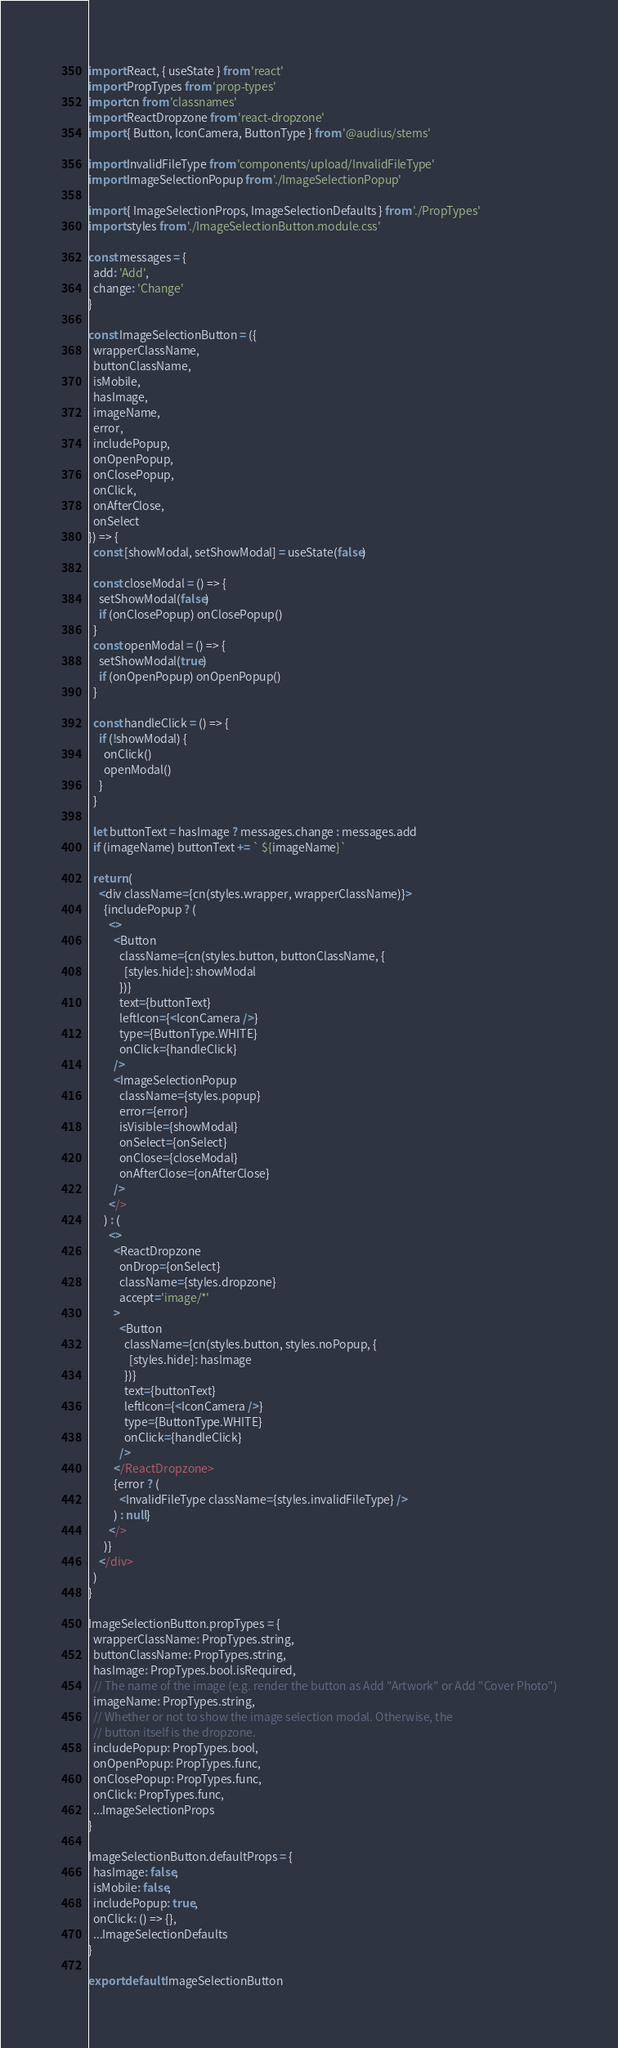Convert code to text. <code><loc_0><loc_0><loc_500><loc_500><_JavaScript_>import React, { useState } from 'react'
import PropTypes from 'prop-types'
import cn from 'classnames'
import ReactDropzone from 'react-dropzone'
import { Button, IconCamera, ButtonType } from '@audius/stems'

import InvalidFileType from 'components/upload/InvalidFileType'
import ImageSelectionPopup from './ImageSelectionPopup'

import { ImageSelectionProps, ImageSelectionDefaults } from './PropTypes'
import styles from './ImageSelectionButton.module.css'

const messages = {
  add: 'Add',
  change: 'Change'
}

const ImageSelectionButton = ({
  wrapperClassName,
  buttonClassName,
  isMobile,
  hasImage,
  imageName,
  error,
  includePopup,
  onOpenPopup,
  onClosePopup,
  onClick,
  onAfterClose,
  onSelect
}) => {
  const [showModal, setShowModal] = useState(false)

  const closeModal = () => {
    setShowModal(false)
    if (onClosePopup) onClosePopup()
  }
  const openModal = () => {
    setShowModal(true)
    if (onOpenPopup) onOpenPopup()
  }

  const handleClick = () => {
    if (!showModal) {
      onClick()
      openModal()
    }
  }

  let buttonText = hasImage ? messages.change : messages.add
  if (imageName) buttonText += ` ${imageName}`

  return (
    <div className={cn(styles.wrapper, wrapperClassName)}>
      {includePopup ? (
        <>
          <Button
            className={cn(styles.button, buttonClassName, {
              [styles.hide]: showModal
            })}
            text={buttonText}
            leftIcon={<IconCamera />}
            type={ButtonType.WHITE}
            onClick={handleClick}
          />
          <ImageSelectionPopup
            className={styles.popup}
            error={error}
            isVisible={showModal}
            onSelect={onSelect}
            onClose={closeModal}
            onAfterClose={onAfterClose}
          />
        </>
      ) : (
        <>
          <ReactDropzone
            onDrop={onSelect}
            className={styles.dropzone}
            accept='image/*'
          >
            <Button
              className={cn(styles.button, styles.noPopup, {
                [styles.hide]: hasImage
              })}
              text={buttonText}
              leftIcon={<IconCamera />}
              type={ButtonType.WHITE}
              onClick={handleClick}
            />
          </ReactDropzone>
          {error ? (
            <InvalidFileType className={styles.invalidFileType} />
          ) : null}
        </>
      )}
    </div>
  )
}

ImageSelectionButton.propTypes = {
  wrapperClassName: PropTypes.string,
  buttonClassName: PropTypes.string,
  hasImage: PropTypes.bool.isRequired,
  // The name of the image (e.g. render the button as Add "Artwork" or Add "Cover Photo")
  imageName: PropTypes.string,
  // Whether or not to show the image selection modal. Otherwise, the
  // button itself is the dropzone.
  includePopup: PropTypes.bool,
  onOpenPopup: PropTypes.func,
  onClosePopup: PropTypes.func,
  onClick: PropTypes.func,
  ...ImageSelectionProps
}

ImageSelectionButton.defaultProps = {
  hasImage: false,
  isMobile: false,
  includePopup: true,
  onClick: () => {},
  ...ImageSelectionDefaults
}

export default ImageSelectionButton
</code> 